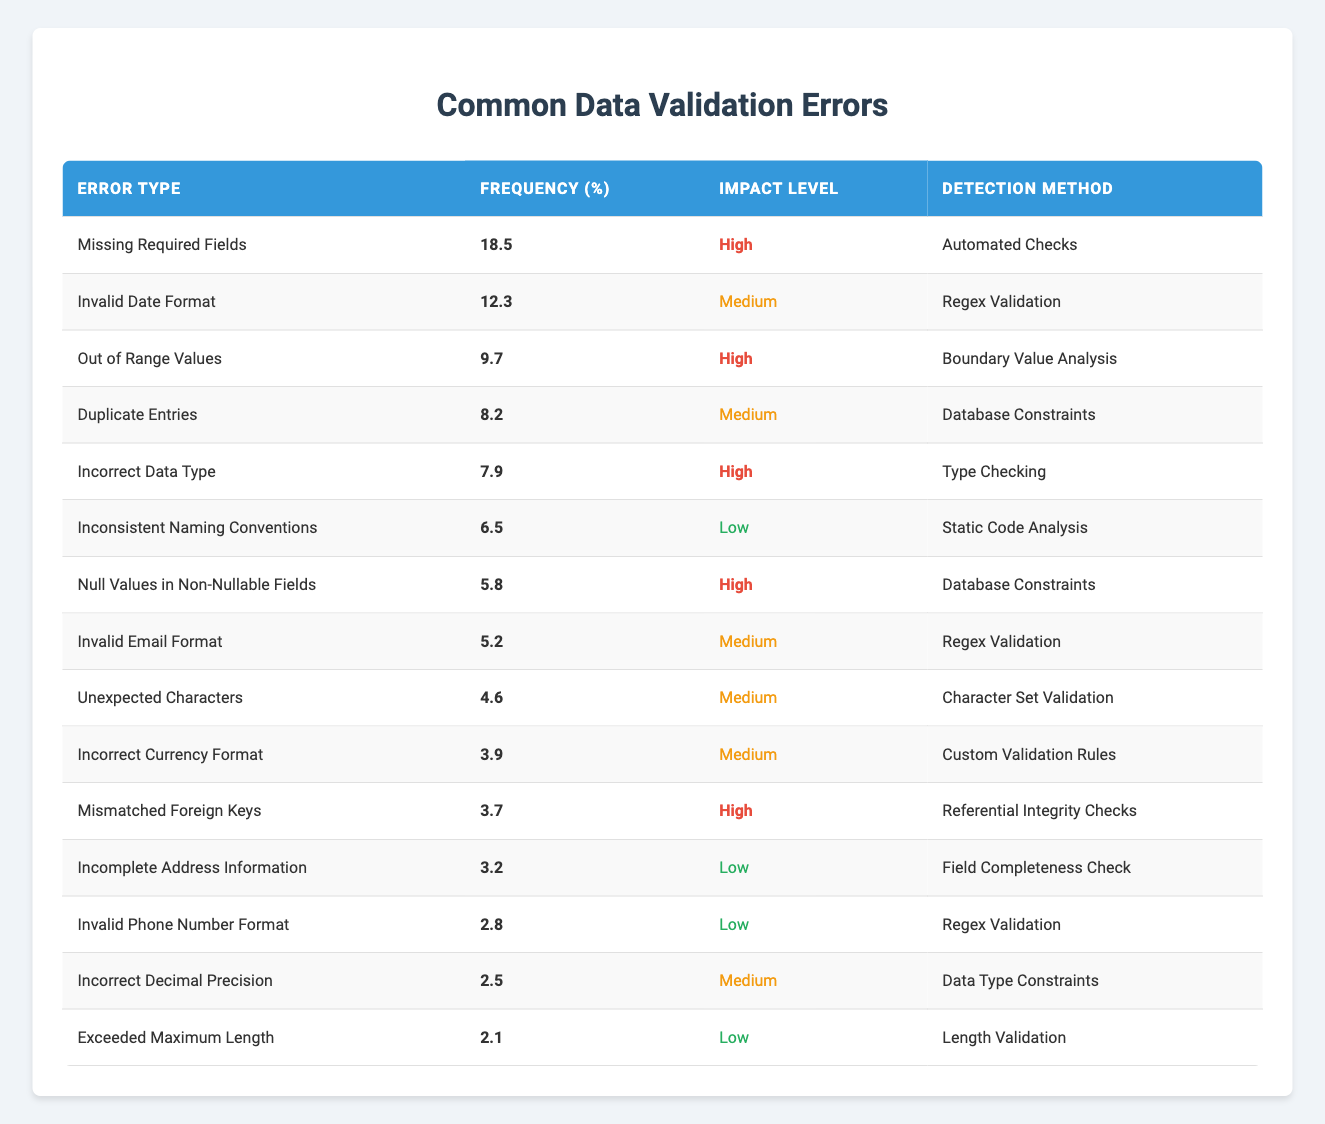What is the most common data validation error? The most common data validation error can be found in the "Error Type" column by identifying the row with the highest frequency percentage. "Missing Required Fields" has the highest frequency of 18.5%.
Answer: Missing Required Fields How many errors have a high impact level? To find the number of errors with a high impact level, I will count the rows where "Impact Level" is "High". The relevant errors are "Missing Required Fields", "Out of Range Values", "Incorrect Data Type", "Null Values in Non-Nullable Fields", and "Mismatched Foreign Keys". Thus, there are 5 errors.
Answer: 5 What is the frequency percentage of "Invalid Email Format"? I can directly locate the "Invalid Email Format" row and check its "Frequency (%)" column, which shows that it is 5.2%.
Answer: 5.2 Which error has the lowest impact level and how frequently does it occur? Looking for the error with the lowest impact level in the "Impact Level" column, "Inconsistent Naming Conventions" is low frequency of 6.5%. Also, "Incomplete Address Information" and "Invalid Phone Number Format" are both low, with frequencies of 3.2% and 2.8%, respectively. The lowest frequency error is "Exceeded Maximum Length" at 2.1%.
Answer: Exceeded Maximum Length, 2.1% Is "Invalid Date Format" more frequent than "Duplicate Entries"? To answer this, I will compare the frequency percentages. "Invalid Date Format" has a frequency of 12.3%, while "Duplicate Entries" has a frequency of 8.2%. Therefore, "Invalid Date Format" is indeed more frequent.
Answer: Yes What is the total frequency percentage of all 'Medium' impact level errors? I will sum the frequency percentages of all errors labeled as "Medium": 12.3 (Invalid Date Format) + 8.2 (Duplicate Entries) + 5.2 (Invalid Email Format) + 4.6 (Unexpected Characters) + 3.9 (Incorrect Currency Format) + 2.5 (Incorrect Decimal Precision) = 36.7%.
Answer: 36.7% Do any errors have a frequency percentage below 3%? I can check the "Frequency (%)" column for values below 3%. The only error with a frequency below 3% is "Exceeded Maximum Length", which has a frequency of 2.1%. Therefore, the answer is yes, there is one error that meets this criterion.
Answer: Yes Which validation error has a frequency closest to 3%? To determine this, I will need to identify the smallest frequency percentage greater than 3%. Scanning the frequencies, "Incomplete Address Information" has 3.2%, which is the closest to 3%.
Answer: Incomplete Address Information What are the detection methods for the error with the highest frequency? The error with the highest frequency is "Missing Required Fields", and its "Detection Method" is "Automated Checks".
Answer: Automated Checks 